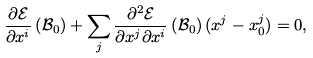<formula> <loc_0><loc_0><loc_500><loc_500>\frac { \partial \mathcal { E } } { \partial x ^ { i } } \left ( \mathcal { B } _ { 0 } \right ) + \sum _ { j } \frac { \partial ^ { 2 } \mathcal { E } } { \partial x ^ { j } \partial x ^ { i } } \left ( \mathcal { B } _ { 0 } \right ) ( x ^ { j } - x _ { 0 } ^ { j } ) = 0 ,</formula> 